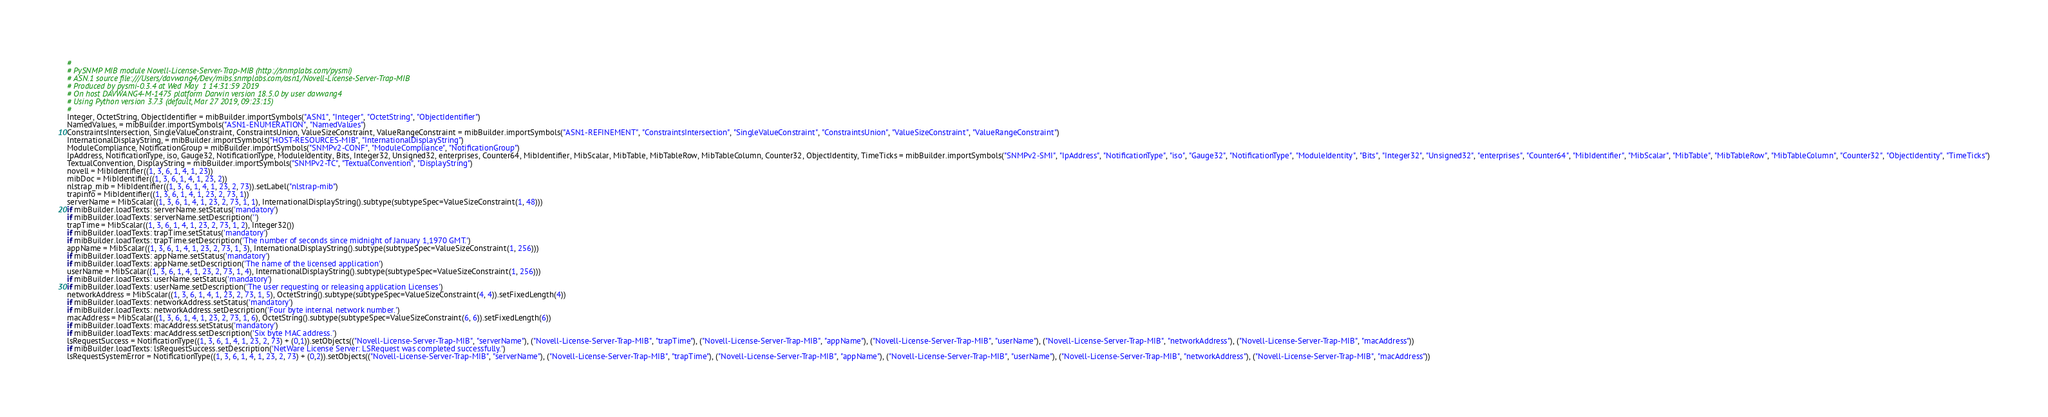Convert code to text. <code><loc_0><loc_0><loc_500><loc_500><_Python_>#
# PySNMP MIB module Novell-License-Server-Trap-MIB (http://snmplabs.com/pysmi)
# ASN.1 source file:///Users/davwang4/Dev/mibs.snmplabs.com/asn1/Novell-License-Server-Trap-MIB
# Produced by pysmi-0.3.4 at Wed May  1 14:31:59 2019
# On host DAVWANG4-M-1475 platform Darwin version 18.5.0 by user davwang4
# Using Python version 3.7.3 (default, Mar 27 2019, 09:23:15) 
#
Integer, OctetString, ObjectIdentifier = mibBuilder.importSymbols("ASN1", "Integer", "OctetString", "ObjectIdentifier")
NamedValues, = mibBuilder.importSymbols("ASN1-ENUMERATION", "NamedValues")
ConstraintsIntersection, SingleValueConstraint, ConstraintsUnion, ValueSizeConstraint, ValueRangeConstraint = mibBuilder.importSymbols("ASN1-REFINEMENT", "ConstraintsIntersection", "SingleValueConstraint", "ConstraintsUnion", "ValueSizeConstraint", "ValueRangeConstraint")
InternationalDisplayString, = mibBuilder.importSymbols("HOST-RESOURCES-MIB", "InternationalDisplayString")
ModuleCompliance, NotificationGroup = mibBuilder.importSymbols("SNMPv2-CONF", "ModuleCompliance", "NotificationGroup")
IpAddress, NotificationType, iso, Gauge32, NotificationType, ModuleIdentity, Bits, Integer32, Unsigned32, enterprises, Counter64, MibIdentifier, MibScalar, MibTable, MibTableRow, MibTableColumn, Counter32, ObjectIdentity, TimeTicks = mibBuilder.importSymbols("SNMPv2-SMI", "IpAddress", "NotificationType", "iso", "Gauge32", "NotificationType", "ModuleIdentity", "Bits", "Integer32", "Unsigned32", "enterprises", "Counter64", "MibIdentifier", "MibScalar", "MibTable", "MibTableRow", "MibTableColumn", "Counter32", "ObjectIdentity", "TimeTicks")
TextualConvention, DisplayString = mibBuilder.importSymbols("SNMPv2-TC", "TextualConvention", "DisplayString")
novell = MibIdentifier((1, 3, 6, 1, 4, 1, 23))
mibDoc = MibIdentifier((1, 3, 6, 1, 4, 1, 23, 2))
nlstrap_mib = MibIdentifier((1, 3, 6, 1, 4, 1, 23, 2, 73)).setLabel("nlstrap-mib")
trapinfo = MibIdentifier((1, 3, 6, 1, 4, 1, 23, 2, 73, 1))
serverName = MibScalar((1, 3, 6, 1, 4, 1, 23, 2, 73, 1, 1), InternationalDisplayString().subtype(subtypeSpec=ValueSizeConstraint(1, 48)))
if mibBuilder.loadTexts: serverName.setStatus('mandatory')
if mibBuilder.loadTexts: serverName.setDescription('')
trapTime = MibScalar((1, 3, 6, 1, 4, 1, 23, 2, 73, 1, 2), Integer32())
if mibBuilder.loadTexts: trapTime.setStatus('mandatory')
if mibBuilder.loadTexts: trapTime.setDescription('The number of seconds since midnight of January 1,1970 GMT.')
appName = MibScalar((1, 3, 6, 1, 4, 1, 23, 2, 73, 1, 3), InternationalDisplayString().subtype(subtypeSpec=ValueSizeConstraint(1, 256)))
if mibBuilder.loadTexts: appName.setStatus('mandatory')
if mibBuilder.loadTexts: appName.setDescription('The name of the licensed application')
userName = MibScalar((1, 3, 6, 1, 4, 1, 23, 2, 73, 1, 4), InternationalDisplayString().subtype(subtypeSpec=ValueSizeConstraint(1, 256)))
if mibBuilder.loadTexts: userName.setStatus('mandatory')
if mibBuilder.loadTexts: userName.setDescription('The user requesting or releasing application Licenses')
networkAddress = MibScalar((1, 3, 6, 1, 4, 1, 23, 2, 73, 1, 5), OctetString().subtype(subtypeSpec=ValueSizeConstraint(4, 4)).setFixedLength(4))
if mibBuilder.loadTexts: networkAddress.setStatus('mandatory')
if mibBuilder.loadTexts: networkAddress.setDescription('Four byte internal network number.')
macAddress = MibScalar((1, 3, 6, 1, 4, 1, 23, 2, 73, 1, 6), OctetString().subtype(subtypeSpec=ValueSizeConstraint(6, 6)).setFixedLength(6))
if mibBuilder.loadTexts: macAddress.setStatus('mandatory')
if mibBuilder.loadTexts: macAddress.setDescription('Six byte MAC address.')
lsRequestSuccess = NotificationType((1, 3, 6, 1, 4, 1, 23, 2, 73) + (0,1)).setObjects(("Novell-License-Server-Trap-MIB", "serverName"), ("Novell-License-Server-Trap-MIB", "trapTime"), ("Novell-License-Server-Trap-MIB", "appName"), ("Novell-License-Server-Trap-MIB", "userName"), ("Novell-License-Server-Trap-MIB", "networkAddress"), ("Novell-License-Server-Trap-MIB", "macAddress"))
if mibBuilder.loadTexts: lsRequestSuccess.setDescription('NetWare License Server: LSRequest was completed successfully.')
lsRequestSystemError = NotificationType((1, 3, 6, 1, 4, 1, 23, 2, 73) + (0,2)).setObjects(("Novell-License-Server-Trap-MIB", "serverName"), ("Novell-License-Server-Trap-MIB", "trapTime"), ("Novell-License-Server-Trap-MIB", "appName"), ("Novell-License-Server-Trap-MIB", "userName"), ("Novell-License-Server-Trap-MIB", "networkAddress"), ("Novell-License-Server-Trap-MIB", "macAddress"))</code> 